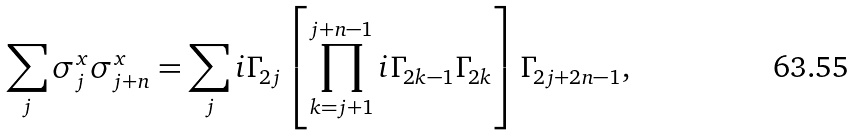<formula> <loc_0><loc_0><loc_500><loc_500>\sum _ { j } \sigma ^ { x } _ { j } \sigma ^ { x } _ { j + n } = \sum _ { j } i \Gamma _ { 2 j } \left [ \prod _ { k = j + 1 } ^ { j + n - 1 } i \Gamma _ { 2 k - 1 } \Gamma _ { 2 k } \right ] \Gamma _ { 2 j + 2 n - 1 } ,</formula> 